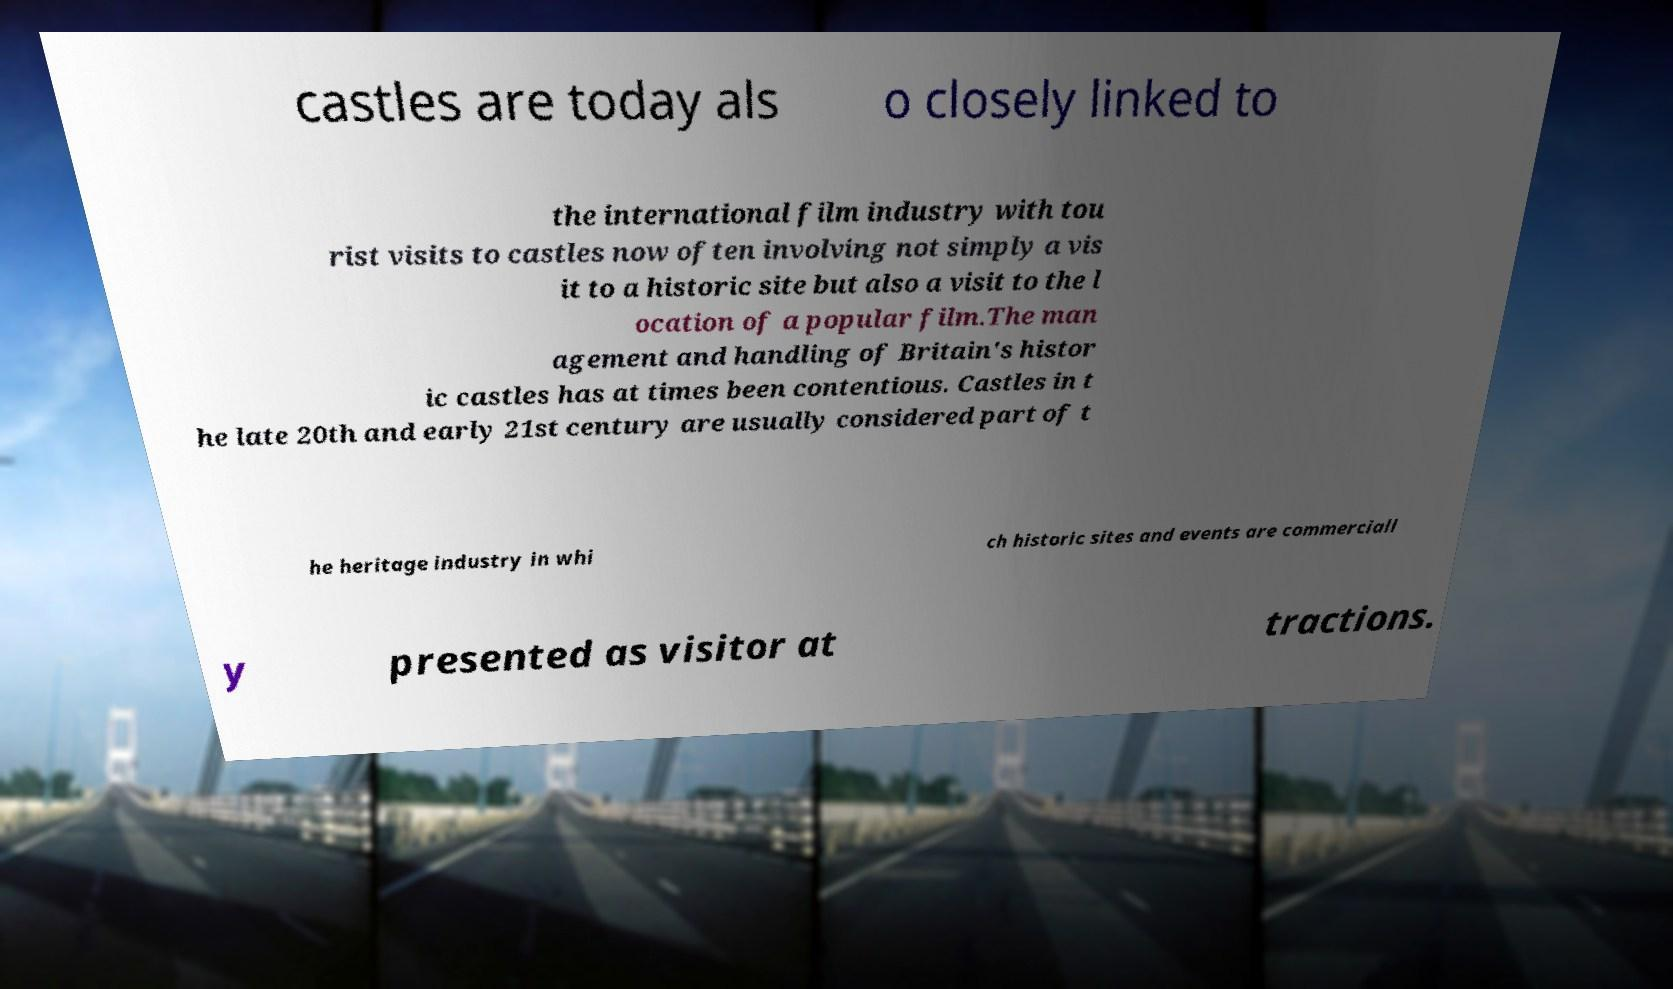Can you accurately transcribe the text from the provided image for me? castles are today als o closely linked to the international film industry with tou rist visits to castles now often involving not simply a vis it to a historic site but also a visit to the l ocation of a popular film.The man agement and handling of Britain's histor ic castles has at times been contentious. Castles in t he late 20th and early 21st century are usually considered part of t he heritage industry in whi ch historic sites and events are commerciall y presented as visitor at tractions. 